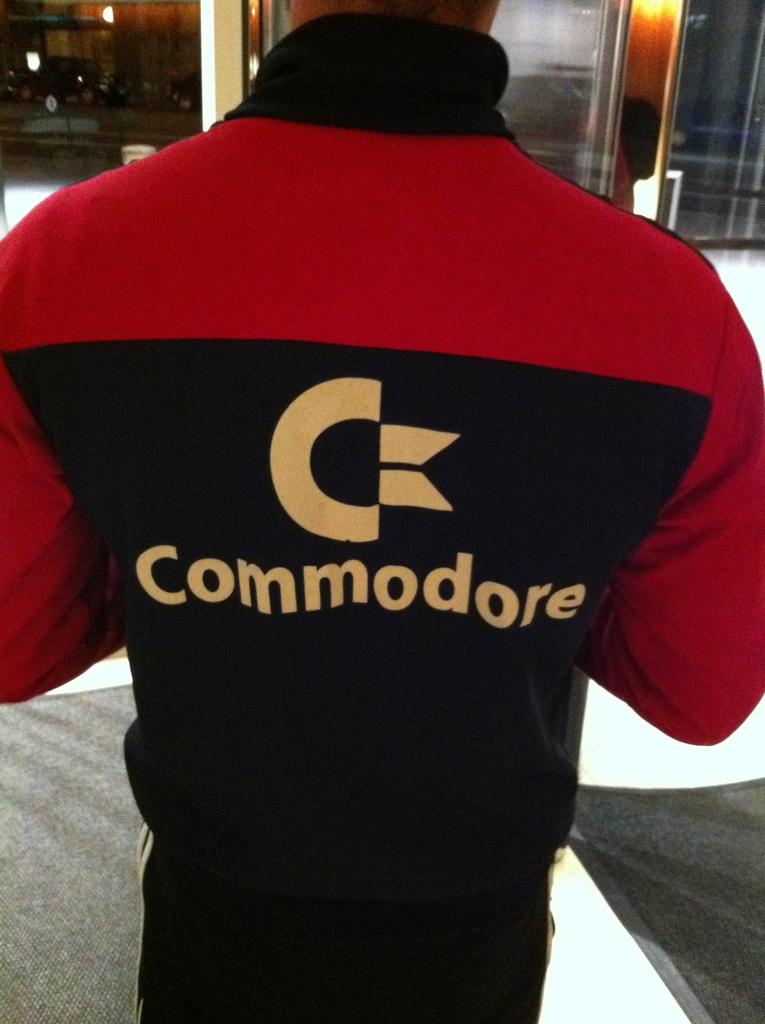What is the main subject of the image? There is a person standing in the image. What can be seen beneath the person's feet? The floor is visible in the image. What is present in the background of the image? There are lights in the background of the image. What type of string can be seen tied around the person's waist in the image? There is no string tied around the person's waist in the image. What industry is depicted in the image? The image does not depict any specific industry; it simply shows a person standing on a floor with lights in the background. 